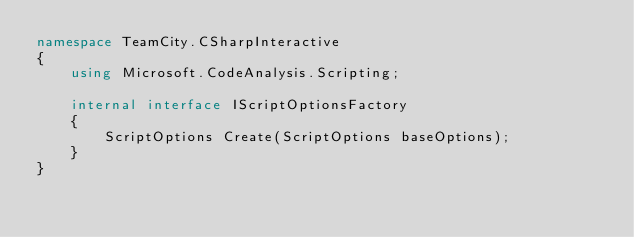<code> <loc_0><loc_0><loc_500><loc_500><_C#_>namespace TeamCity.CSharpInteractive
{
    using Microsoft.CodeAnalysis.Scripting;

    internal interface IScriptOptionsFactory
    {
        ScriptOptions Create(ScriptOptions baseOptions);
    }
}</code> 